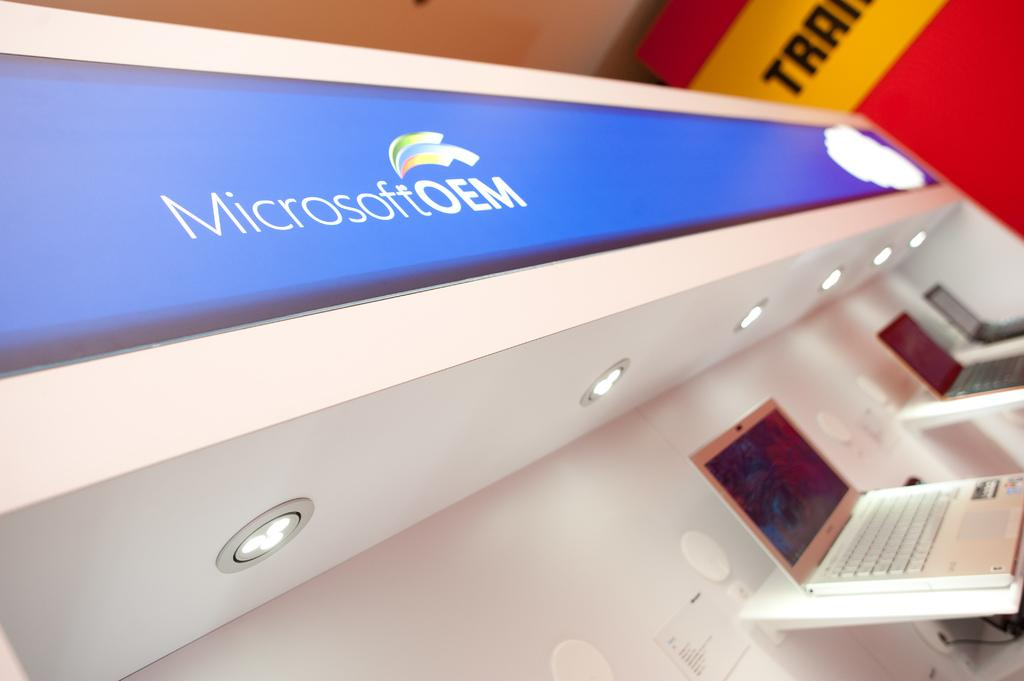<image>
Give a short and clear explanation of the subsequent image. The MicrosoftOEM logo can be seen above lights. 